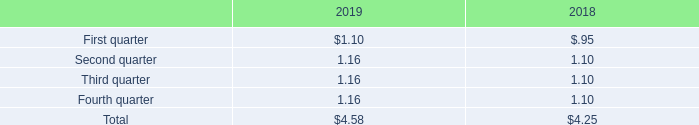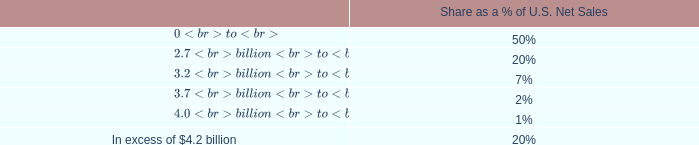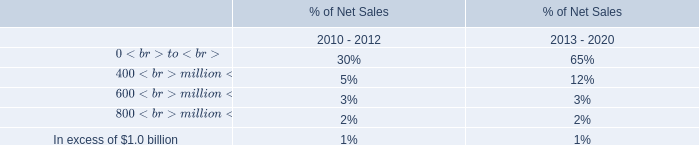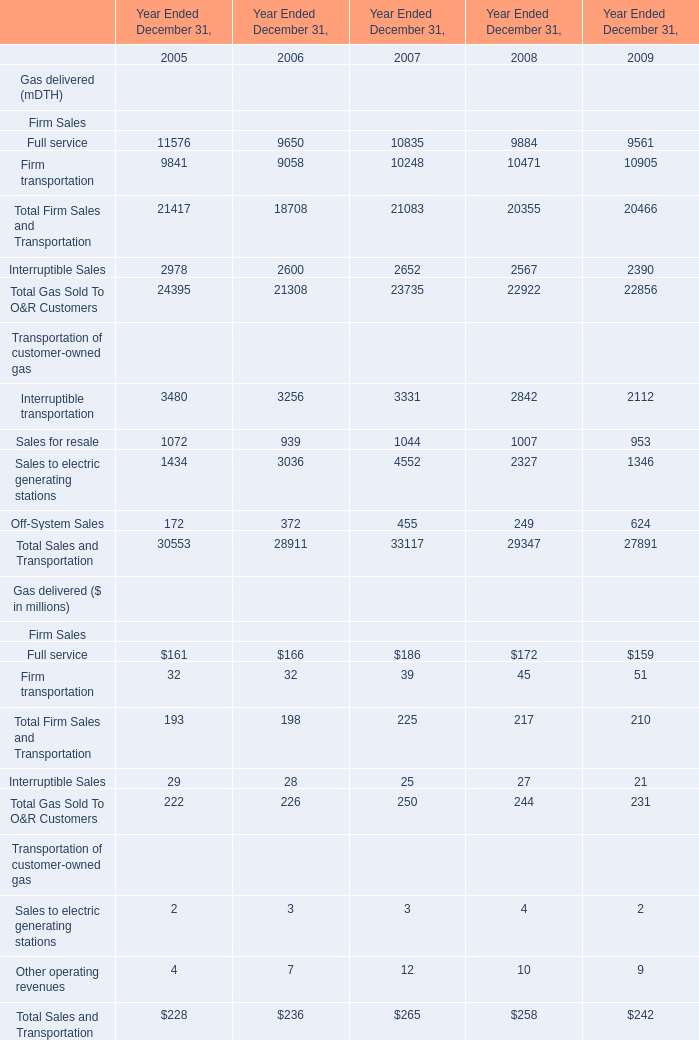What is the percentage of all Firm Sales that are positive to the total amount, in 2005 for Gas delivered (mDTH)? 
Computations: ((9841 + 11576) / 21417)
Answer: 1.0. 